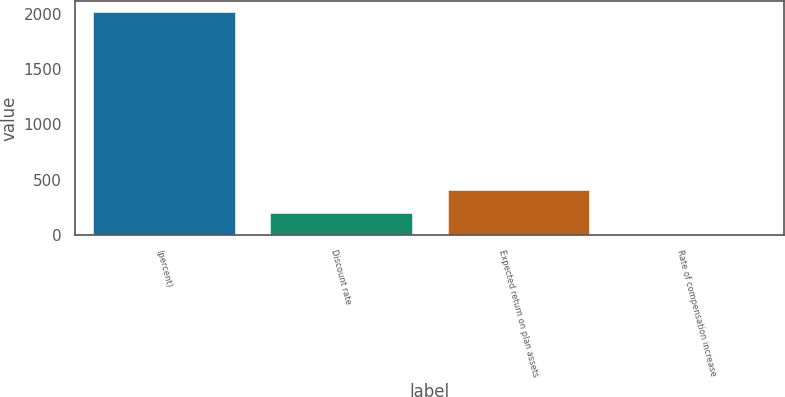Convert chart to OTSL. <chart><loc_0><loc_0><loc_500><loc_500><bar_chart><fcel>(percent)<fcel>Discount rate<fcel>Expected return on plan assets<fcel>Rate of compensation increase<nl><fcel>2010<fcel>203.48<fcel>404.21<fcel>2.75<nl></chart> 